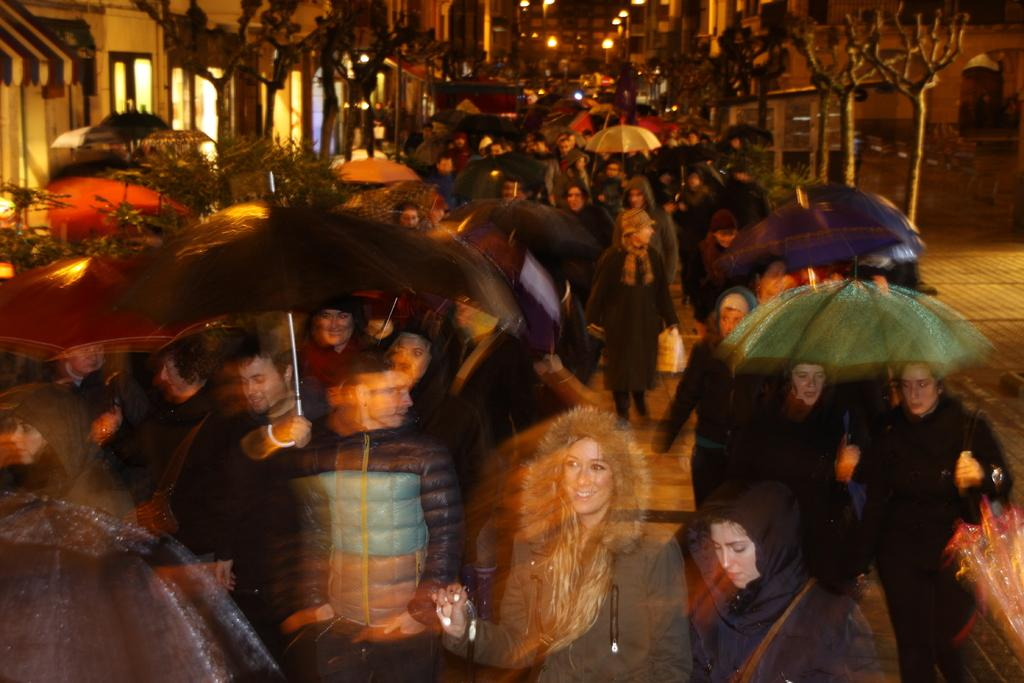What can be seen in the image involving multiple individuals? There are groups of people standing in the image. What are some people using to protect themselves from the elements? Some people are holding umbrellas. What type of natural vegetation is present in the image? There are trees in the image. What type of man-made structures can be seen in the image? There are buildings visible in the image. What type of rod is being used by the people in the image? There is no rod visible in the image; people are holding umbrellas instead. Can you describe the group of trees in the image? There is no specific group of trees mentioned in the image; only individual trees are present. 